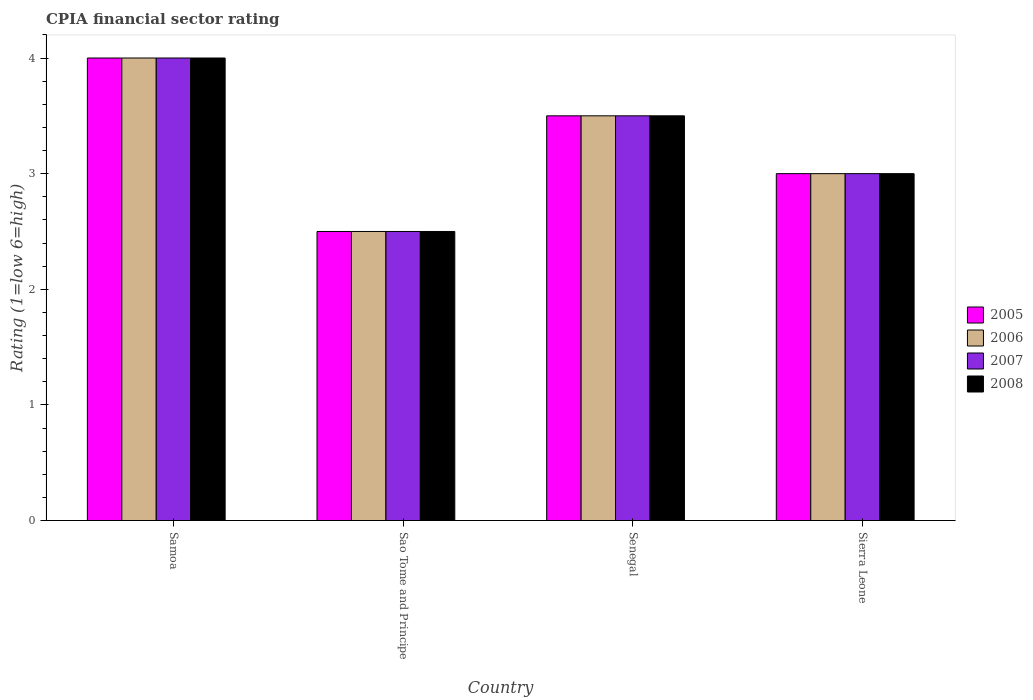How many different coloured bars are there?
Keep it short and to the point. 4. How many groups of bars are there?
Offer a terse response. 4. Are the number of bars per tick equal to the number of legend labels?
Provide a succinct answer. Yes. Are the number of bars on each tick of the X-axis equal?
Your answer should be compact. Yes. How many bars are there on the 2nd tick from the left?
Your answer should be very brief. 4. How many bars are there on the 4th tick from the right?
Ensure brevity in your answer.  4. What is the label of the 1st group of bars from the left?
Provide a succinct answer. Samoa. In how many cases, is the number of bars for a given country not equal to the number of legend labels?
Provide a short and direct response. 0. What is the CPIA rating in 2006 in Sao Tome and Principe?
Your answer should be very brief. 2.5. Across all countries, what is the maximum CPIA rating in 2008?
Provide a short and direct response. 4. Across all countries, what is the minimum CPIA rating in 2006?
Offer a very short reply. 2.5. In which country was the CPIA rating in 2006 maximum?
Your response must be concise. Samoa. In which country was the CPIA rating in 2008 minimum?
Give a very brief answer. Sao Tome and Principe. What is the difference between the CPIA rating in 2005 in Samoa and that in Senegal?
Offer a terse response. 0.5. What is the difference between the CPIA rating of/in 2005 and CPIA rating of/in 2006 in Samoa?
Ensure brevity in your answer.  0. In how many countries, is the CPIA rating in 2006 greater than 0.2?
Give a very brief answer. 4. What is the ratio of the CPIA rating in 2008 in Senegal to that in Sierra Leone?
Keep it short and to the point. 1.17. Is the difference between the CPIA rating in 2005 in Samoa and Senegal greater than the difference between the CPIA rating in 2006 in Samoa and Senegal?
Make the answer very short. No. What is the difference between the highest and the lowest CPIA rating in 2008?
Ensure brevity in your answer.  1.5. Is it the case that in every country, the sum of the CPIA rating in 2007 and CPIA rating in 2005 is greater than the sum of CPIA rating in 2006 and CPIA rating in 2008?
Provide a succinct answer. No. What does the 3rd bar from the left in Sierra Leone represents?
Make the answer very short. 2007. Are all the bars in the graph horizontal?
Make the answer very short. No. How many countries are there in the graph?
Provide a succinct answer. 4. Are the values on the major ticks of Y-axis written in scientific E-notation?
Your answer should be compact. No. Does the graph contain any zero values?
Offer a terse response. No. How many legend labels are there?
Offer a terse response. 4. What is the title of the graph?
Your response must be concise. CPIA financial sector rating. Does "1999" appear as one of the legend labels in the graph?
Ensure brevity in your answer.  No. What is the label or title of the Y-axis?
Provide a succinct answer. Rating (1=low 6=high). What is the Rating (1=low 6=high) of 2006 in Samoa?
Give a very brief answer. 4. What is the Rating (1=low 6=high) of 2007 in Samoa?
Your response must be concise. 4. What is the Rating (1=low 6=high) of 2008 in Samoa?
Your answer should be compact. 4. What is the Rating (1=low 6=high) in 2005 in Sao Tome and Principe?
Ensure brevity in your answer.  2.5. What is the Rating (1=low 6=high) in 2006 in Sao Tome and Principe?
Keep it short and to the point. 2.5. What is the Rating (1=low 6=high) of 2008 in Sao Tome and Principe?
Your answer should be compact. 2.5. What is the Rating (1=low 6=high) of 2005 in Senegal?
Make the answer very short. 3.5. What is the Rating (1=low 6=high) of 2006 in Senegal?
Make the answer very short. 3.5. What is the Rating (1=low 6=high) of 2008 in Senegal?
Make the answer very short. 3.5. What is the Rating (1=low 6=high) of 2006 in Sierra Leone?
Provide a short and direct response. 3. Across all countries, what is the maximum Rating (1=low 6=high) in 2006?
Offer a terse response. 4. Across all countries, what is the maximum Rating (1=low 6=high) of 2007?
Ensure brevity in your answer.  4. Across all countries, what is the minimum Rating (1=low 6=high) in 2006?
Offer a terse response. 2.5. Across all countries, what is the minimum Rating (1=low 6=high) of 2008?
Offer a very short reply. 2.5. What is the total Rating (1=low 6=high) in 2006 in the graph?
Provide a succinct answer. 13. What is the difference between the Rating (1=low 6=high) of 2005 in Samoa and that in Sao Tome and Principe?
Offer a very short reply. 1.5. What is the difference between the Rating (1=low 6=high) in 2006 in Samoa and that in Sao Tome and Principe?
Provide a succinct answer. 1.5. What is the difference between the Rating (1=low 6=high) in 2007 in Samoa and that in Sao Tome and Principe?
Provide a short and direct response. 1.5. What is the difference between the Rating (1=low 6=high) in 2007 in Samoa and that in Senegal?
Your response must be concise. 0.5. What is the difference between the Rating (1=low 6=high) in 2005 in Samoa and that in Sierra Leone?
Offer a very short reply. 1. What is the difference between the Rating (1=low 6=high) of 2007 in Samoa and that in Sierra Leone?
Ensure brevity in your answer.  1. What is the difference between the Rating (1=low 6=high) in 2005 in Sao Tome and Principe and that in Senegal?
Provide a succinct answer. -1. What is the difference between the Rating (1=low 6=high) in 2008 in Sao Tome and Principe and that in Senegal?
Provide a short and direct response. -1. What is the difference between the Rating (1=low 6=high) in 2005 in Sao Tome and Principe and that in Sierra Leone?
Keep it short and to the point. -0.5. What is the difference between the Rating (1=low 6=high) of 2007 in Sao Tome and Principe and that in Sierra Leone?
Your response must be concise. -0.5. What is the difference between the Rating (1=low 6=high) of 2007 in Senegal and that in Sierra Leone?
Provide a succinct answer. 0.5. What is the difference between the Rating (1=low 6=high) in 2008 in Senegal and that in Sierra Leone?
Offer a very short reply. 0.5. What is the difference between the Rating (1=low 6=high) of 2005 in Samoa and the Rating (1=low 6=high) of 2007 in Sao Tome and Principe?
Offer a terse response. 1.5. What is the difference between the Rating (1=low 6=high) in 2006 in Samoa and the Rating (1=low 6=high) in 2008 in Sao Tome and Principe?
Your response must be concise. 1.5. What is the difference between the Rating (1=low 6=high) of 2005 in Samoa and the Rating (1=low 6=high) of 2006 in Senegal?
Your answer should be compact. 0.5. What is the difference between the Rating (1=low 6=high) of 2005 in Samoa and the Rating (1=low 6=high) of 2007 in Senegal?
Provide a short and direct response. 0.5. What is the difference between the Rating (1=low 6=high) in 2005 in Samoa and the Rating (1=low 6=high) in 2008 in Senegal?
Provide a short and direct response. 0.5. What is the difference between the Rating (1=low 6=high) in 2005 in Samoa and the Rating (1=low 6=high) in 2007 in Sierra Leone?
Provide a short and direct response. 1. What is the difference between the Rating (1=low 6=high) of 2006 in Samoa and the Rating (1=low 6=high) of 2007 in Sierra Leone?
Your answer should be very brief. 1. What is the difference between the Rating (1=low 6=high) of 2005 in Sao Tome and Principe and the Rating (1=low 6=high) of 2006 in Senegal?
Your answer should be very brief. -1. What is the difference between the Rating (1=low 6=high) in 2005 in Sao Tome and Principe and the Rating (1=low 6=high) in 2007 in Senegal?
Offer a terse response. -1. What is the difference between the Rating (1=low 6=high) of 2005 in Sao Tome and Principe and the Rating (1=low 6=high) of 2008 in Senegal?
Your response must be concise. -1. What is the difference between the Rating (1=low 6=high) in 2006 in Sao Tome and Principe and the Rating (1=low 6=high) in 2008 in Senegal?
Make the answer very short. -1. What is the difference between the Rating (1=low 6=high) of 2007 in Sao Tome and Principe and the Rating (1=low 6=high) of 2008 in Senegal?
Provide a succinct answer. -1. What is the difference between the Rating (1=low 6=high) in 2006 in Sao Tome and Principe and the Rating (1=low 6=high) in 2008 in Sierra Leone?
Ensure brevity in your answer.  -0.5. What is the difference between the Rating (1=low 6=high) of 2005 in Senegal and the Rating (1=low 6=high) of 2007 in Sierra Leone?
Keep it short and to the point. 0.5. What is the difference between the Rating (1=low 6=high) in 2006 in Senegal and the Rating (1=low 6=high) in 2008 in Sierra Leone?
Give a very brief answer. 0.5. What is the average Rating (1=low 6=high) of 2005 per country?
Offer a very short reply. 3.25. What is the average Rating (1=low 6=high) in 2006 per country?
Provide a succinct answer. 3.25. What is the average Rating (1=low 6=high) in 2007 per country?
Your answer should be compact. 3.25. What is the difference between the Rating (1=low 6=high) in 2005 and Rating (1=low 6=high) in 2006 in Samoa?
Make the answer very short. 0. What is the difference between the Rating (1=low 6=high) of 2005 and Rating (1=low 6=high) of 2007 in Samoa?
Keep it short and to the point. 0. What is the difference between the Rating (1=low 6=high) in 2005 and Rating (1=low 6=high) in 2008 in Samoa?
Offer a very short reply. 0. What is the difference between the Rating (1=low 6=high) in 2006 and Rating (1=low 6=high) in 2007 in Samoa?
Your answer should be very brief. 0. What is the difference between the Rating (1=low 6=high) in 2007 and Rating (1=low 6=high) in 2008 in Samoa?
Make the answer very short. 0. What is the difference between the Rating (1=low 6=high) of 2005 and Rating (1=low 6=high) of 2008 in Sao Tome and Principe?
Provide a succinct answer. 0. What is the difference between the Rating (1=low 6=high) of 2006 and Rating (1=low 6=high) of 2007 in Sao Tome and Principe?
Keep it short and to the point. 0. What is the difference between the Rating (1=low 6=high) in 2006 and Rating (1=low 6=high) in 2008 in Sao Tome and Principe?
Your response must be concise. 0. What is the difference between the Rating (1=low 6=high) in 2005 and Rating (1=low 6=high) in 2007 in Senegal?
Make the answer very short. 0. What is the difference between the Rating (1=low 6=high) of 2005 and Rating (1=low 6=high) of 2008 in Senegal?
Keep it short and to the point. 0. What is the difference between the Rating (1=low 6=high) in 2006 and Rating (1=low 6=high) in 2008 in Senegal?
Provide a succinct answer. 0. What is the difference between the Rating (1=low 6=high) of 2005 and Rating (1=low 6=high) of 2006 in Sierra Leone?
Provide a short and direct response. 0. What is the difference between the Rating (1=low 6=high) of 2005 and Rating (1=low 6=high) of 2008 in Sierra Leone?
Your answer should be very brief. 0. What is the difference between the Rating (1=low 6=high) in 2006 and Rating (1=low 6=high) in 2008 in Sierra Leone?
Your answer should be very brief. 0. What is the ratio of the Rating (1=low 6=high) in 2005 in Samoa to that in Sao Tome and Principe?
Provide a short and direct response. 1.6. What is the ratio of the Rating (1=low 6=high) of 2006 in Samoa to that in Sao Tome and Principe?
Give a very brief answer. 1.6. What is the ratio of the Rating (1=low 6=high) in 2008 in Samoa to that in Sao Tome and Principe?
Keep it short and to the point. 1.6. What is the ratio of the Rating (1=low 6=high) of 2006 in Samoa to that in Senegal?
Ensure brevity in your answer.  1.14. What is the ratio of the Rating (1=low 6=high) in 2006 in Samoa to that in Sierra Leone?
Offer a very short reply. 1.33. What is the ratio of the Rating (1=low 6=high) in 2007 in Samoa to that in Sierra Leone?
Provide a succinct answer. 1.33. What is the ratio of the Rating (1=low 6=high) of 2008 in Samoa to that in Sierra Leone?
Provide a succinct answer. 1.33. What is the ratio of the Rating (1=low 6=high) of 2005 in Sao Tome and Principe to that in Senegal?
Your answer should be very brief. 0.71. What is the ratio of the Rating (1=low 6=high) in 2006 in Sao Tome and Principe to that in Senegal?
Offer a terse response. 0.71. What is the ratio of the Rating (1=low 6=high) in 2007 in Sao Tome and Principe to that in Senegal?
Provide a short and direct response. 0.71. What is the ratio of the Rating (1=low 6=high) of 2005 in Sao Tome and Principe to that in Sierra Leone?
Offer a terse response. 0.83. What is the ratio of the Rating (1=low 6=high) in 2007 in Sao Tome and Principe to that in Sierra Leone?
Your answer should be very brief. 0.83. What is the ratio of the Rating (1=low 6=high) in 2007 in Senegal to that in Sierra Leone?
Make the answer very short. 1.17. What is the difference between the highest and the second highest Rating (1=low 6=high) in 2007?
Keep it short and to the point. 0.5. 